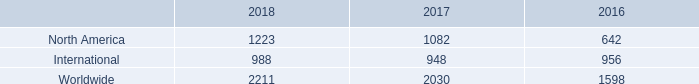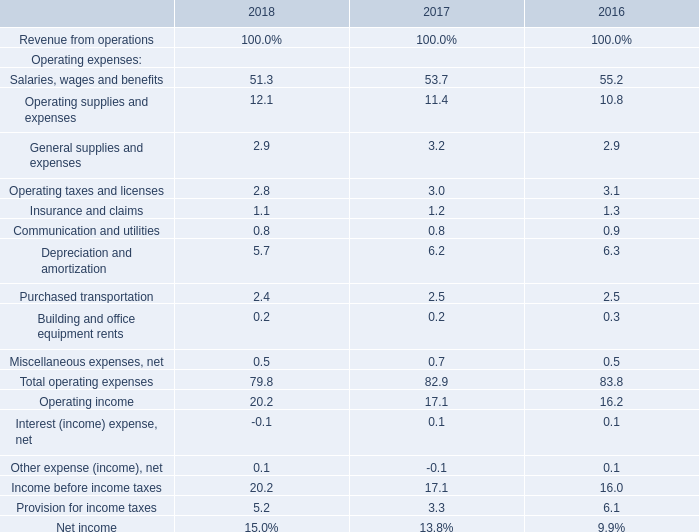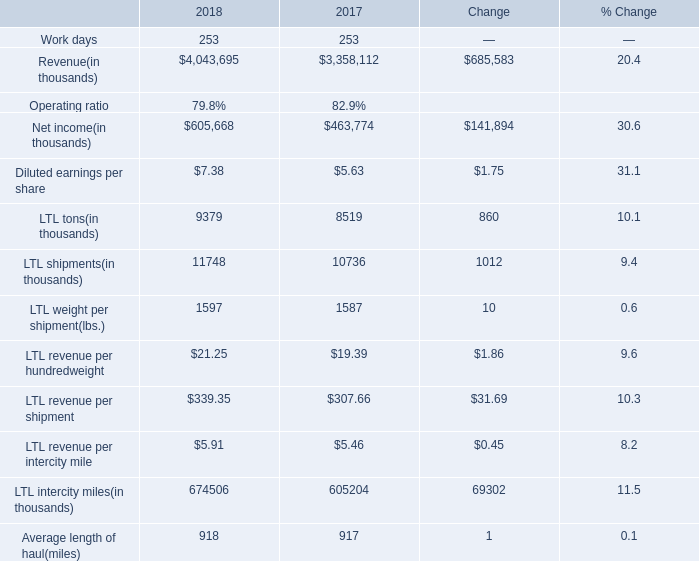If Insurance and claims develops with the same growth rate in 2017, what will it reach in 2018? 
Computations: ((1 + ((1.2 - 1.3) / 1.3)) * 1.2)
Answer: 1.10769. 